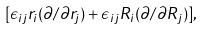Convert formula to latex. <formula><loc_0><loc_0><loc_500><loc_500>[ \epsilon _ { i j } r _ { i } ( \partial / \partial r _ { j } ) + \epsilon _ { i j } R _ { i } ( \partial / \partial R _ { j } ) ] ,</formula> 